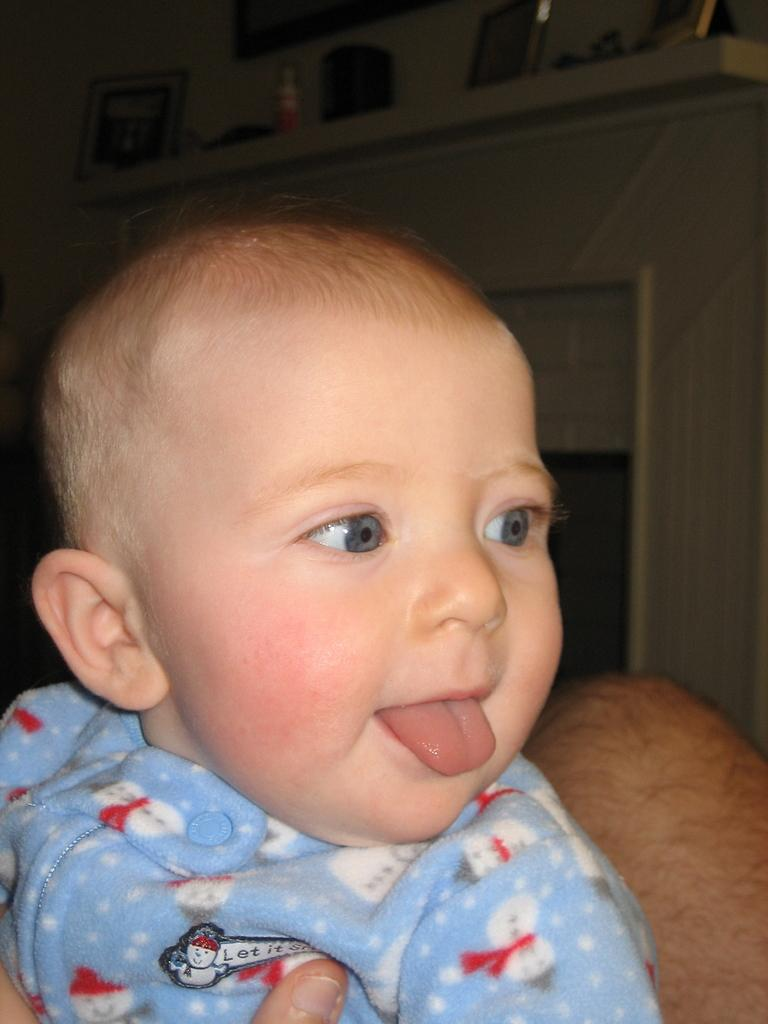What is the main subject of the image? There is a kid in the image. Can you describe the shirt the kid is wearing? The kid is wearing a shirt with blue, red, and white colors. What can be seen in the background of the image? There is a shelf in the background of the image. What is on the shelf? There are items arranged on the shelf. What type of paste is being used to force the items on the shelf to stay in place? There is no paste or force mentioned in the image. The items on the shelf are simply arranged there. 